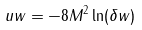Convert formula to latex. <formula><loc_0><loc_0><loc_500><loc_500>u w = - 8 M ^ { 2 } \ln ( \delta w )</formula> 